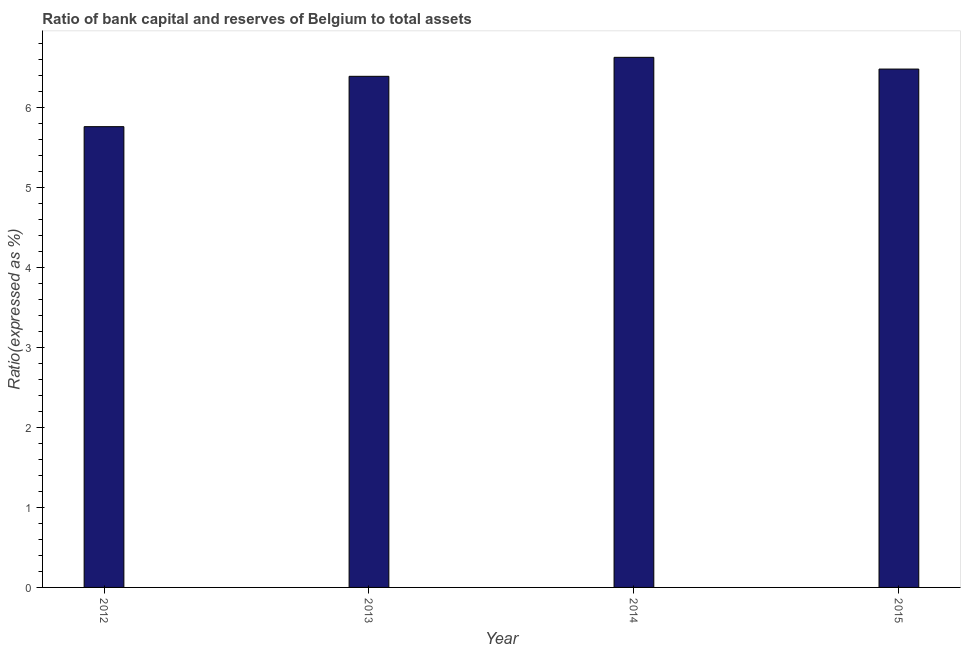Does the graph contain any zero values?
Provide a short and direct response. No. Does the graph contain grids?
Offer a very short reply. No. What is the title of the graph?
Offer a terse response. Ratio of bank capital and reserves of Belgium to total assets. What is the label or title of the Y-axis?
Keep it short and to the point. Ratio(expressed as %). What is the bank capital to assets ratio in 2014?
Provide a succinct answer. 6.63. Across all years, what is the maximum bank capital to assets ratio?
Ensure brevity in your answer.  6.63. Across all years, what is the minimum bank capital to assets ratio?
Your answer should be compact. 5.76. In which year was the bank capital to assets ratio minimum?
Offer a very short reply. 2012. What is the sum of the bank capital to assets ratio?
Provide a short and direct response. 25.26. What is the difference between the bank capital to assets ratio in 2012 and 2013?
Make the answer very short. -0.63. What is the average bank capital to assets ratio per year?
Make the answer very short. 6.32. What is the median bank capital to assets ratio?
Provide a succinct answer. 6.44. Do a majority of the years between 2015 and 2012 (inclusive) have bank capital to assets ratio greater than 1.4 %?
Make the answer very short. Yes. What is the ratio of the bank capital to assets ratio in 2012 to that in 2014?
Provide a short and direct response. 0.87. Is the bank capital to assets ratio in 2013 less than that in 2014?
Provide a short and direct response. Yes. What is the difference between the highest and the second highest bank capital to assets ratio?
Your answer should be very brief. 0.15. Is the sum of the bank capital to assets ratio in 2012 and 2015 greater than the maximum bank capital to assets ratio across all years?
Provide a succinct answer. Yes. What is the difference between the highest and the lowest bank capital to assets ratio?
Offer a very short reply. 0.87. How many bars are there?
Keep it short and to the point. 4. Are all the bars in the graph horizontal?
Provide a short and direct response. No. How many years are there in the graph?
Ensure brevity in your answer.  4. What is the difference between two consecutive major ticks on the Y-axis?
Make the answer very short. 1. Are the values on the major ticks of Y-axis written in scientific E-notation?
Provide a succinct answer. No. What is the Ratio(expressed as %) of 2012?
Your answer should be compact. 5.76. What is the Ratio(expressed as %) of 2013?
Give a very brief answer. 6.39. What is the Ratio(expressed as %) in 2014?
Offer a very short reply. 6.63. What is the Ratio(expressed as %) in 2015?
Your response must be concise. 6.48. What is the difference between the Ratio(expressed as %) in 2012 and 2013?
Make the answer very short. -0.63. What is the difference between the Ratio(expressed as %) in 2012 and 2014?
Your answer should be compact. -0.87. What is the difference between the Ratio(expressed as %) in 2012 and 2015?
Offer a very short reply. -0.72. What is the difference between the Ratio(expressed as %) in 2013 and 2014?
Provide a short and direct response. -0.24. What is the difference between the Ratio(expressed as %) in 2013 and 2015?
Offer a very short reply. -0.09. What is the difference between the Ratio(expressed as %) in 2014 and 2015?
Give a very brief answer. 0.15. What is the ratio of the Ratio(expressed as %) in 2012 to that in 2013?
Give a very brief answer. 0.9. What is the ratio of the Ratio(expressed as %) in 2012 to that in 2014?
Keep it short and to the point. 0.87. What is the ratio of the Ratio(expressed as %) in 2012 to that in 2015?
Your answer should be very brief. 0.89. What is the ratio of the Ratio(expressed as %) in 2013 to that in 2014?
Your response must be concise. 0.96. 